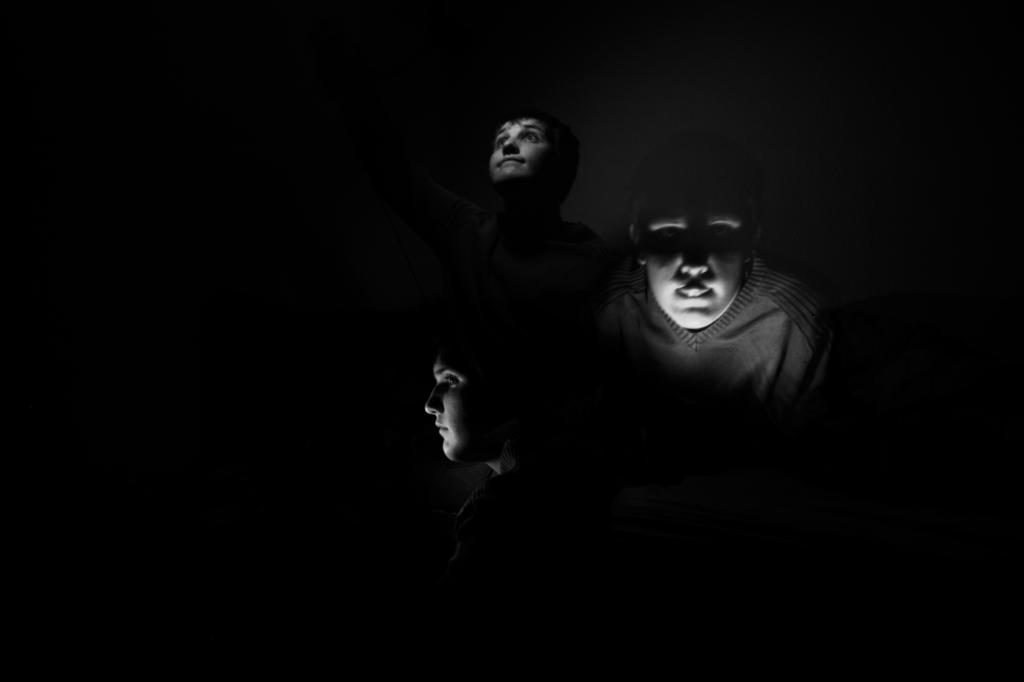How many people are in the image? There are three people in the image. What is the color scheme of the image? The image is black and white. Can you describe the lighting in the image? The image is dark. How many frogs can be seen in the image? There are no frogs present in the image. What type of selection process is depicted in the image? There is no selection process depicted in the image. 